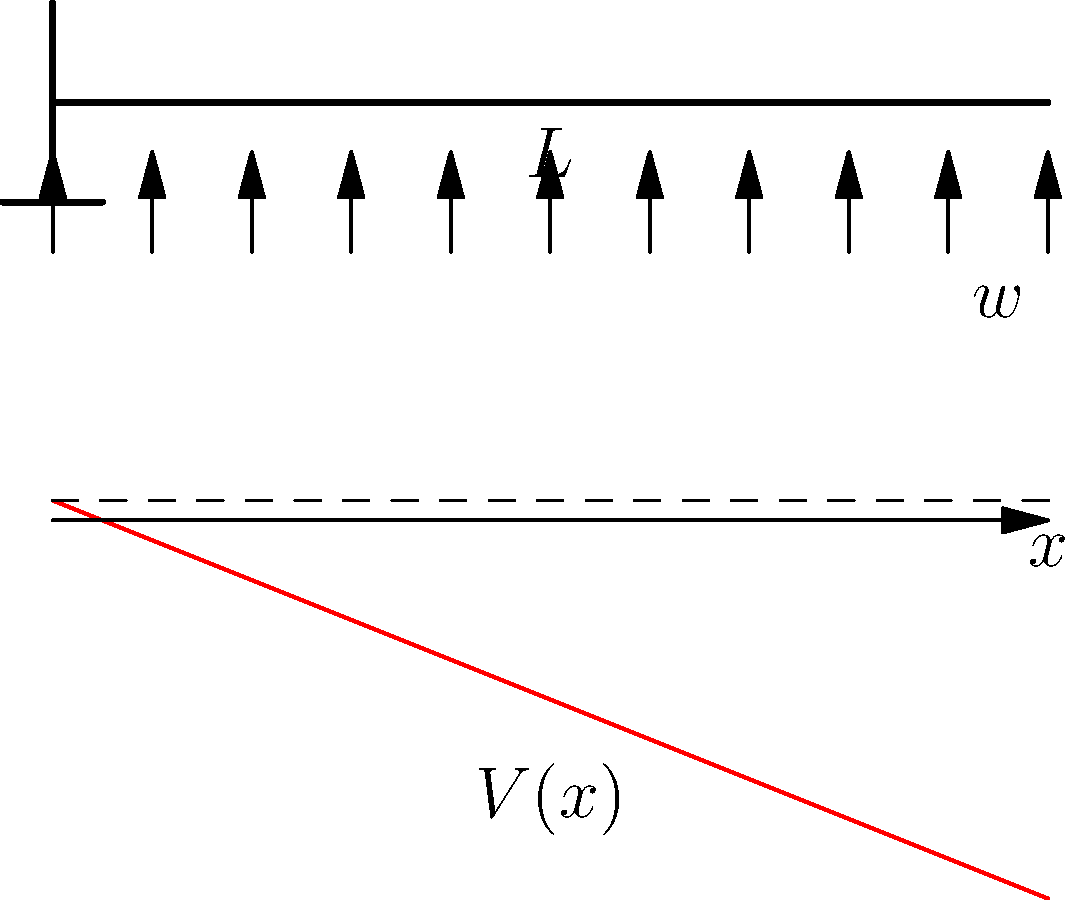As a civil engineer, you're analyzing a cantilever beam of length $L$ with a uniformly distributed load $w$. How would you express the shear force $V(x)$ at any point $x$ along the beam's length? Let's approach this step-by-step:

1) In a cantilever beam, one end is fixed, and the other end is free. The fixed end (at $x=0$) supports the entire load.

2) The total load on the beam is $wL$, where $w$ is the load per unit length and $L$ is the total length of the beam.

3) At any point $x$ along the beam, the shear force $V(x)$ is equal to the total load to the right of that point.

4) The load to the right of point $x$ is $w(L-x)$, as $(L-x)$ is the length of beam to the right of point $x$.

5) Therefore, the shear force at any point $x$ can be expressed as:

   $V(x) = w(L-x)$

6) This equation shows that the shear force varies linearly along the beam's length. It's maximum at the fixed end $(x=0)$ where $V(0) = wL$, and zero at the free end $(x=L)$ where $V(L) = 0$.

7) The negative sign in the equation indicates that the shear force acts upward, opposing the downward distributed load.
Answer: $V(x) = w(L-x)$ 